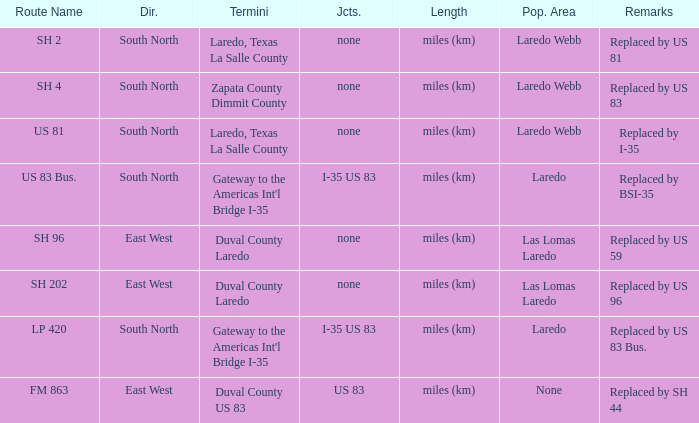Which junctions have "replaced by bsi-35" listed in their remarks section? I-35 US 83. 